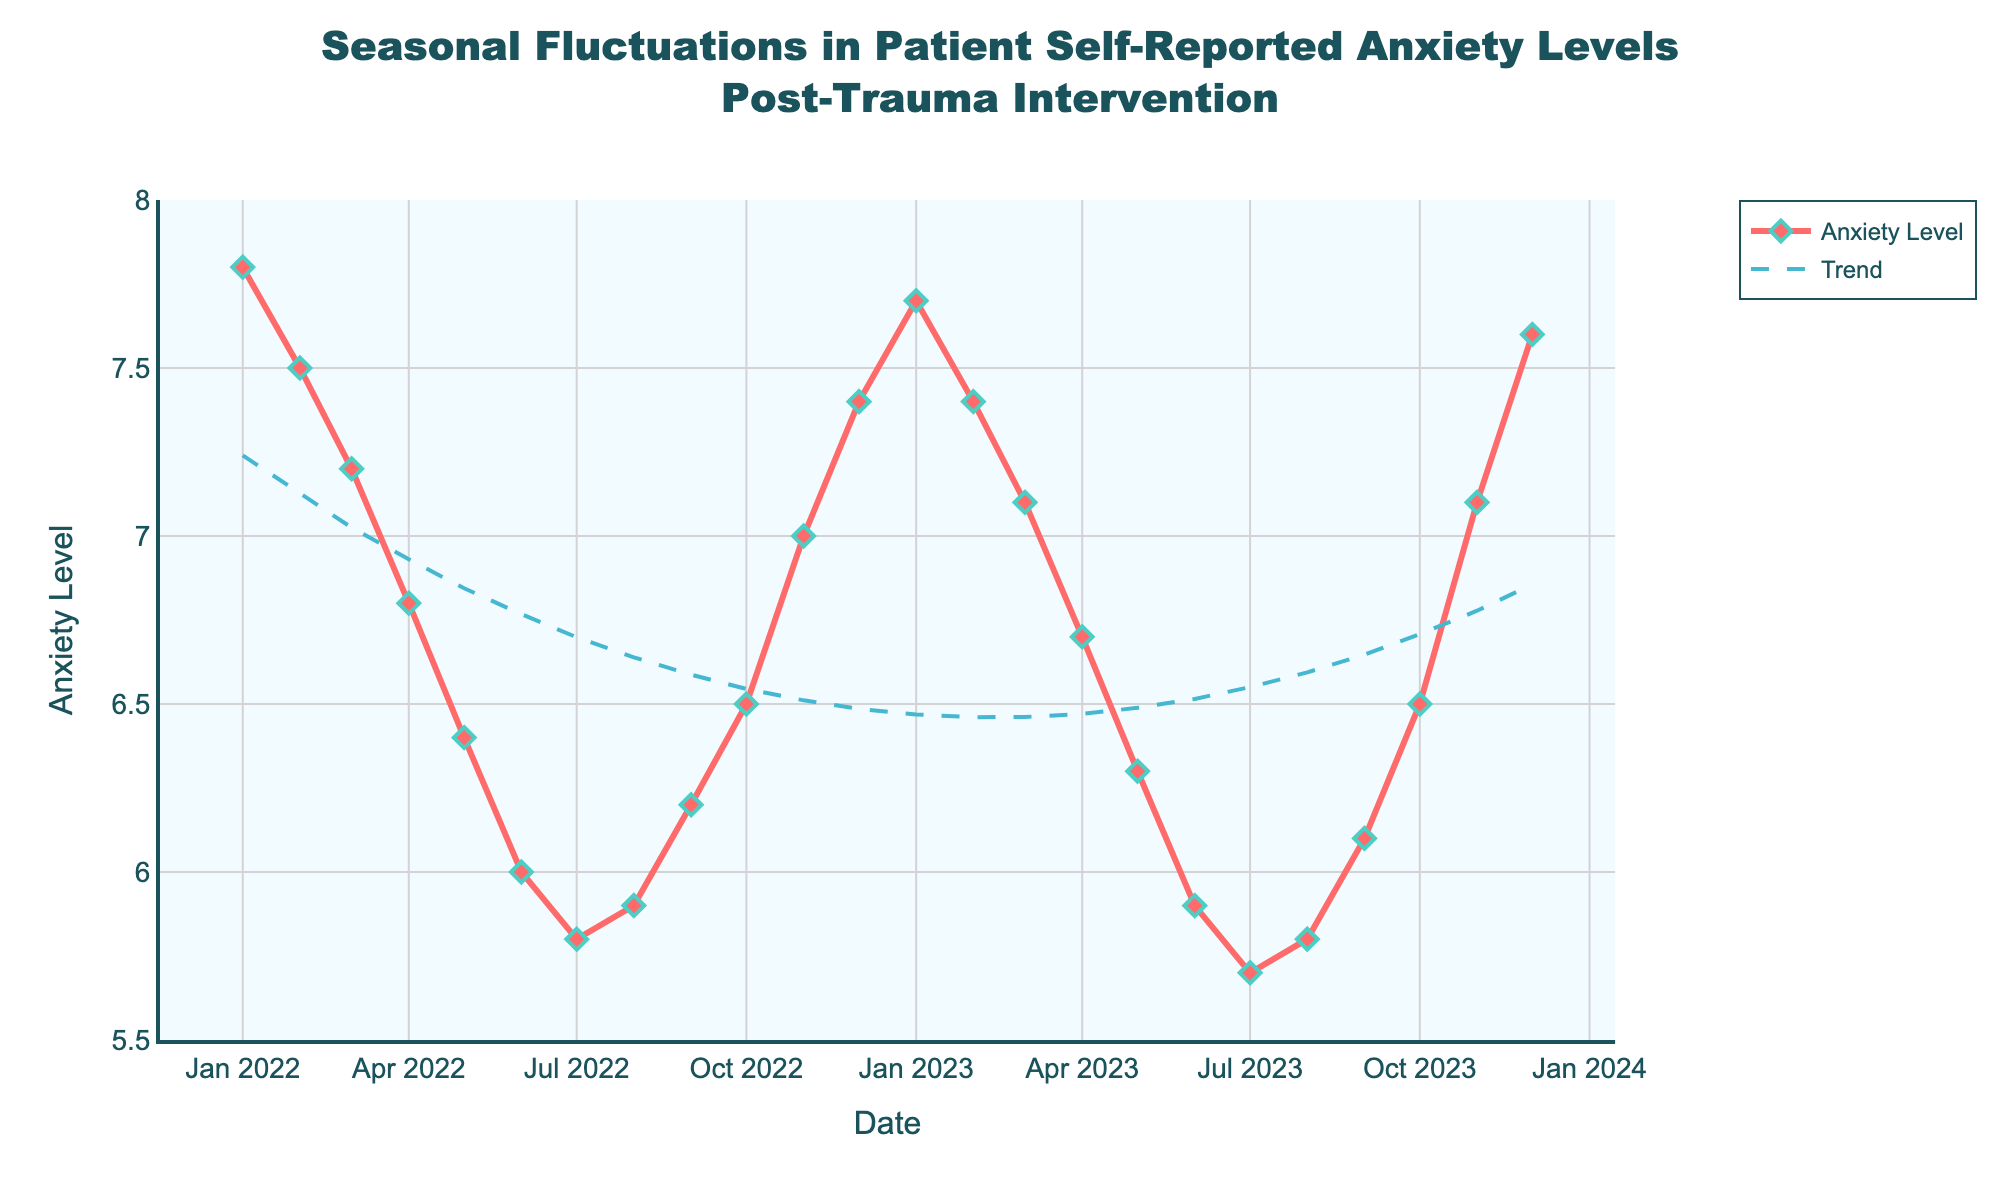What is the title of the figure? The title of the figure appears at the top and provides an overview of the data being presented. In this case, the title is located centrally at the top and includes key phrases like "Seasonal Fluctuations" and "Post-Trauma Intervention."
Answer: Seasonal Fluctuations in Patient Self-Reported Anxiety Levels Post-Trauma Intervention What is the highest anxiety level recorded in the plot? To find the highest anxiety level, look at the y-axis values and identify the peak point in the time series data. The highest peak is noticeable in several months, including January 2022 and some subsequent months.
Answer: 7.8 During which month(s) does the lowest anxiety level occur? The lowest anxiety level can be observed by finding the trough in the time series data, which typically appears in the months with the lowest point on the plot.
Answer: July 2023 How many data points are in the figure? To determine the number of data points, count the markers on the plot. Each marker represents a single data point corresponding to each month's anxiety level.
Answer: 24 Describe the trend of anxiety levels from January 2022 to December 2022. To describe the trend, observe the line plot from the start date to the end date within 2022. Notice the general direction of the line (increasing or decreasing) and any noticeable patterns or fluctuations.
Answer: Decreasing from January to July, then increasing towards December Compare the anxiety levels between January 2022 and January 2023. To compare the anxiety levels, look at the data points for the two specified months and note their respective values. January 2022 has one of the highest values while January 2023 is slightly lower but still high.
Answer: January 2022 is higher than January 2023 What is the general trend line indicating about anxiety levels over the two years? The trend line, usually a smooth curve, helps determine the overall pattern by averaging fluctuations. In this plot, the trend line (dash) depicts the overall movement, which is generally decreasing.
Answer: General decreasing trend Which month shows a noticeable spike in anxiety levels after a period of decrease? Find the month where a prominent spike occurs immediately after a decreasing pattern. Such instances are usually seen after the mid-point of the curve.
Answer: November 2022 Is August 2023's anxiety level higher or lower than August 2022? To determine this, look at the two data points corresponding to August in both years and compare their values visually.
Answer: Lower What is the average anxiety level from January 2022 to December 2022? To calculate the average, sum all the anxiety levels from January 2022 to December 2022, then divide the total by the number of months (12). The sum is 83.9, and the average would be 83.9 / 12.
Answer: 6.99 